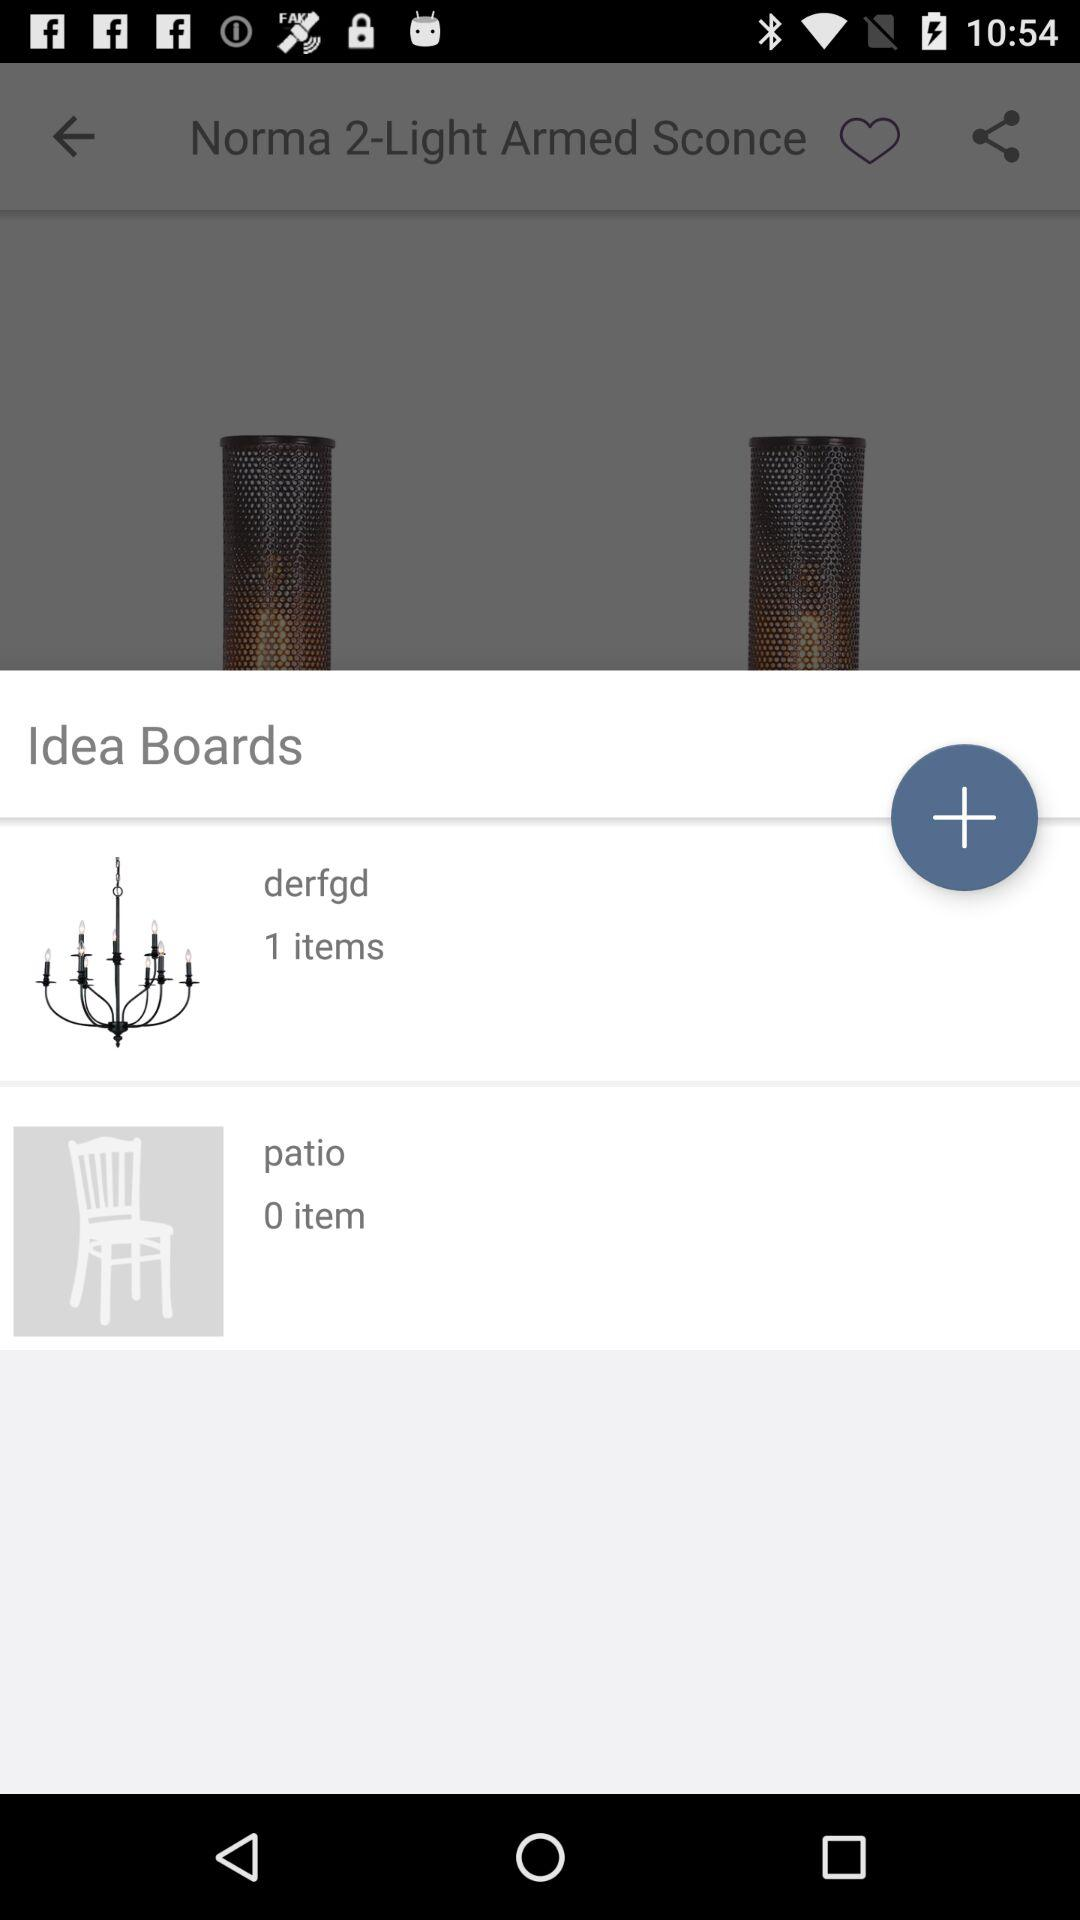How many more items are in the first Idea Board than the second?
Answer the question using a single word or phrase. 1 